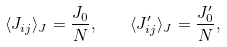<formula> <loc_0><loc_0><loc_500><loc_500>\langle J _ { i j } \rangle _ { J } = \frac { J _ { 0 } } { N } , \quad \langle J ^ { \prime } _ { i j } \rangle _ { J } = \frac { J ^ { \prime } _ { 0 } } { N } ,</formula> 